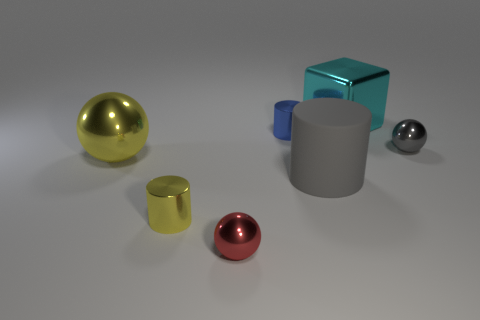Subtract all small metal balls. How many balls are left? 1 Add 1 tiny gray metal objects. How many objects exist? 8 Subtract all gray cylinders. How many cylinders are left? 2 Subtract 0 green spheres. How many objects are left? 7 Subtract all balls. How many objects are left? 4 Subtract 1 balls. How many balls are left? 2 Subtract all blue cylinders. Subtract all brown spheres. How many cylinders are left? 2 Subtract all gray shiny spheres. Subtract all yellow cylinders. How many objects are left? 5 Add 4 large gray matte objects. How many large gray matte objects are left? 5 Add 6 large gray rubber things. How many large gray rubber things exist? 7 